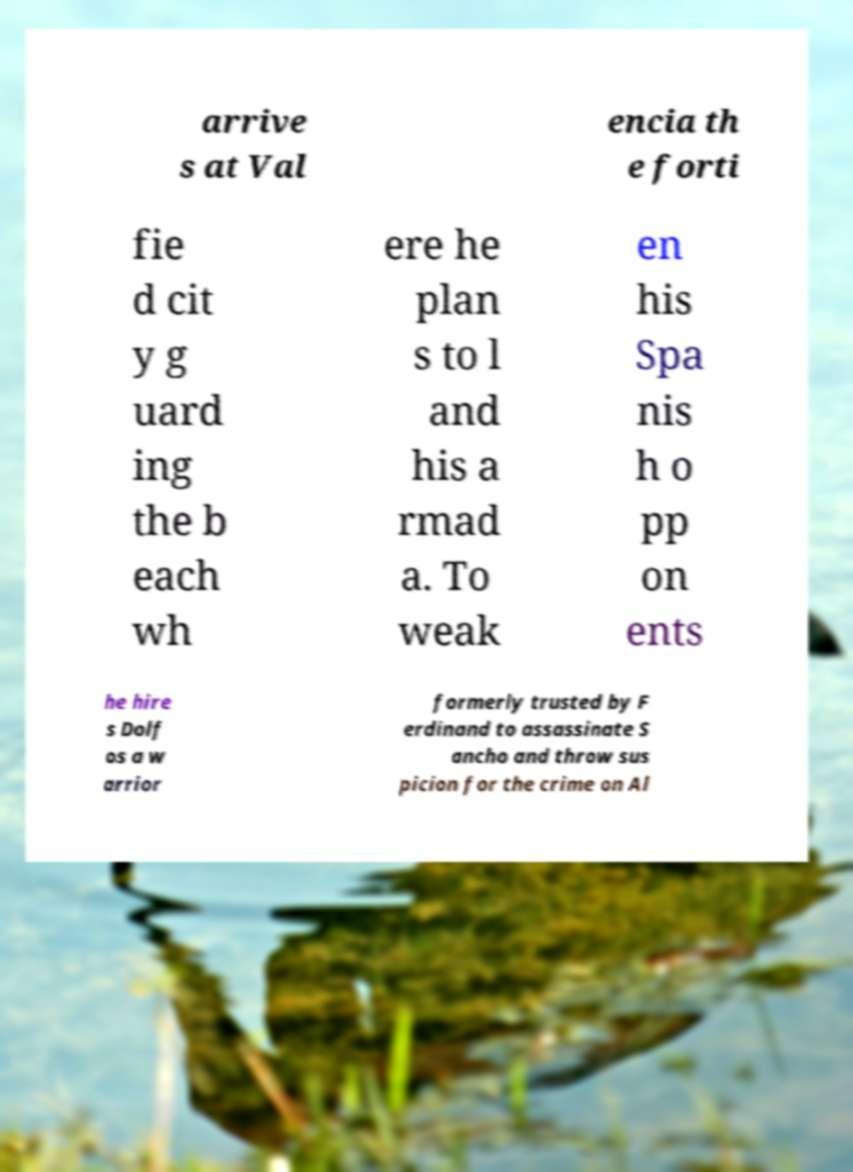Could you extract and type out the text from this image? arrive s at Val encia th e forti fie d cit y g uard ing the b each wh ere he plan s to l and his a rmad a. To weak en his Spa nis h o pp on ents he hire s Dolf os a w arrior formerly trusted by F erdinand to assassinate S ancho and throw sus picion for the crime on Al 